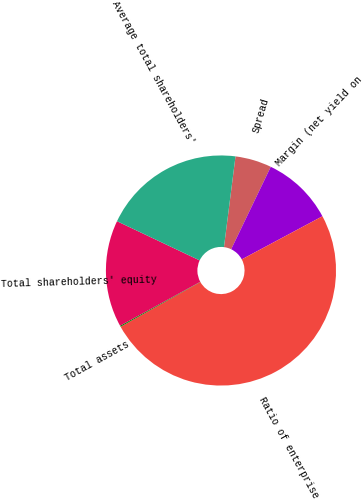Convert chart to OTSL. <chart><loc_0><loc_0><loc_500><loc_500><pie_chart><fcel>Spread<fcel>Margin (net yield on<fcel>Ratio of enterprise<fcel>Total assets<fcel>Total shareholders' equity<fcel>Average total shareholders'<nl><fcel>5.11%<fcel>10.06%<fcel>49.69%<fcel>0.15%<fcel>15.02%<fcel>19.97%<nl></chart> 